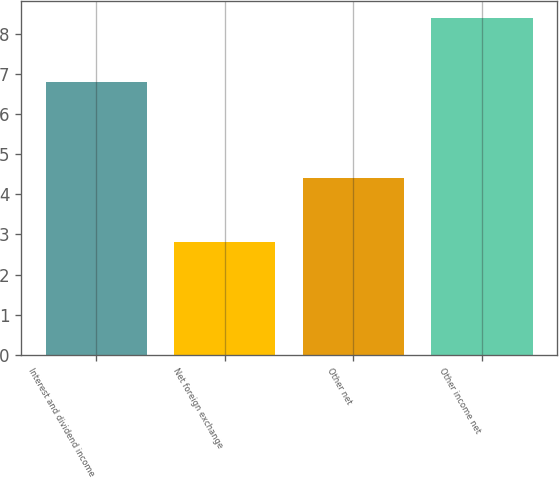Convert chart to OTSL. <chart><loc_0><loc_0><loc_500><loc_500><bar_chart><fcel>Interest and dividend income<fcel>Net foreign exchange<fcel>Other net<fcel>Other income net<nl><fcel>6.8<fcel>2.8<fcel>4.4<fcel>8.4<nl></chart> 